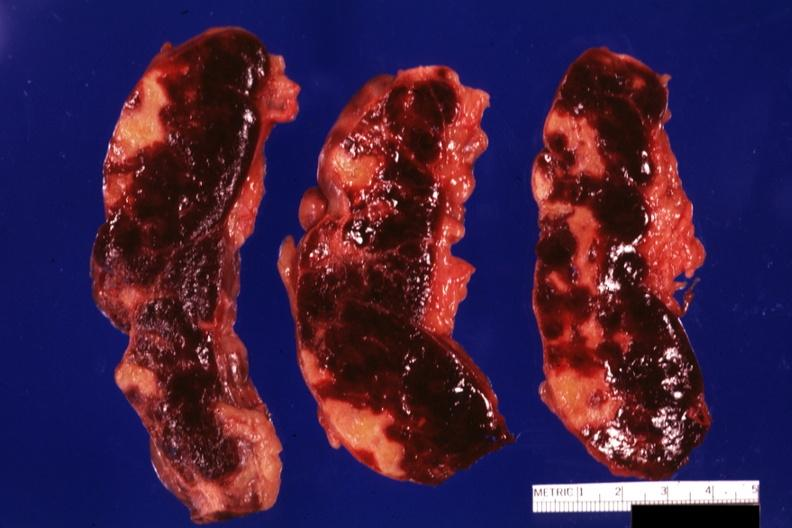s cytomegalovirus present?
Answer the question using a single word or phrase. No 